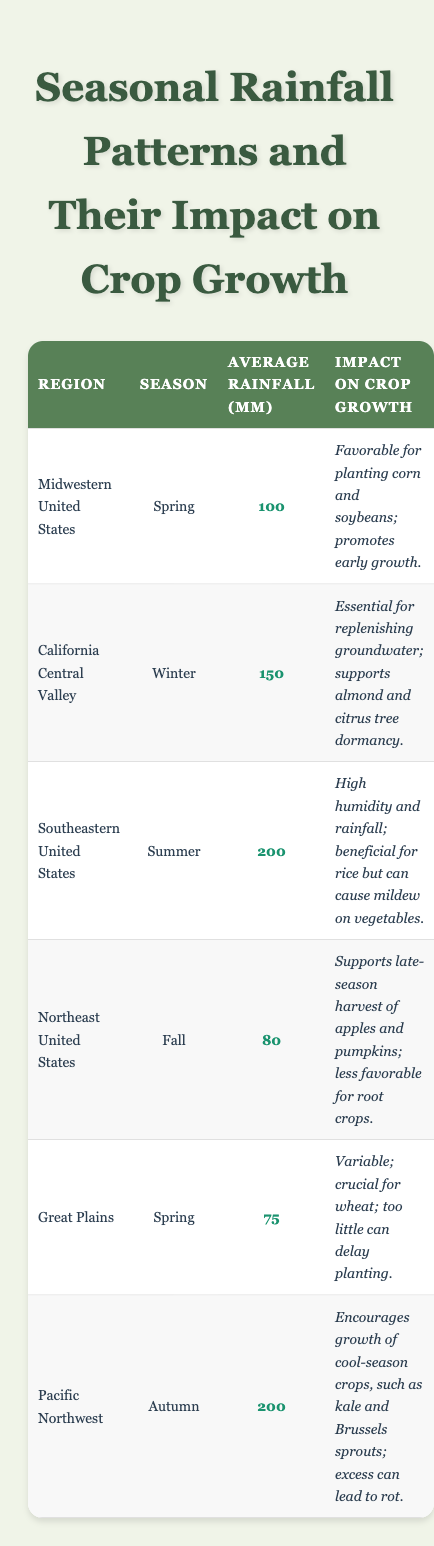What is the average rainfall in the Southeastern United States during summer? The table shows that the average rainfall in the Southeastern United States during summer is 200 mm.
Answer: 200 mm Which region has the highest average rainfall and what is the amount? By comparing the average rainfall values in the table, the Southeastern United States has the highest average rainfall of 200 mm.
Answer: Southeastern United States; 200 mm Does the Great Plains region receive more or less rain in spring compared to the Midwestern United States? In spring, the Great Plains receive 75 mm of rainfall while the Midwestern United States receive 100 mm. Therefore, the Great Plains receive less rain in spring.
Answer: Less In which season does California Central Valley experience its average rainfall, and how does that impact crop growth? The California Central Valley experiences average rainfall in winter, which is essential for replenishing groundwater and supports almond and citrus tree dormancy.
Answer: Winter; essential for crops What is the total average rainfall across all regions listed in the table? To find the total average rainfall, we need to sum the average rainfall for each region: 100 + 150 + 200 + 80 + 75 + 200 = 805 mm.
Answer: 805 mm Which region is least favorable for root crops, and in which season does this occur? The Northeast United States is least favorable for root crops, which occurs in fall when the average rainfall is 80 mm.
Answer: Northeast United States; Fall How many regions have an average rainfall of 100 mm or more? The regions with 100 mm or more average rainfall are the Midwestern United States, California Central Valley, Southeastern United States, and Pacific Northwest. That gives us a total of 4 regions.
Answer: 4 regions What impact does the autumn rainfall have on crop growth in the Pacific Northwest? The autumn rainfall in the Pacific Northwest encourages the growth of cool-season crops like kale and Brussels sprouts, but excess rainfall can lead to rot.
Answer: Encourages growth but can cause rot 